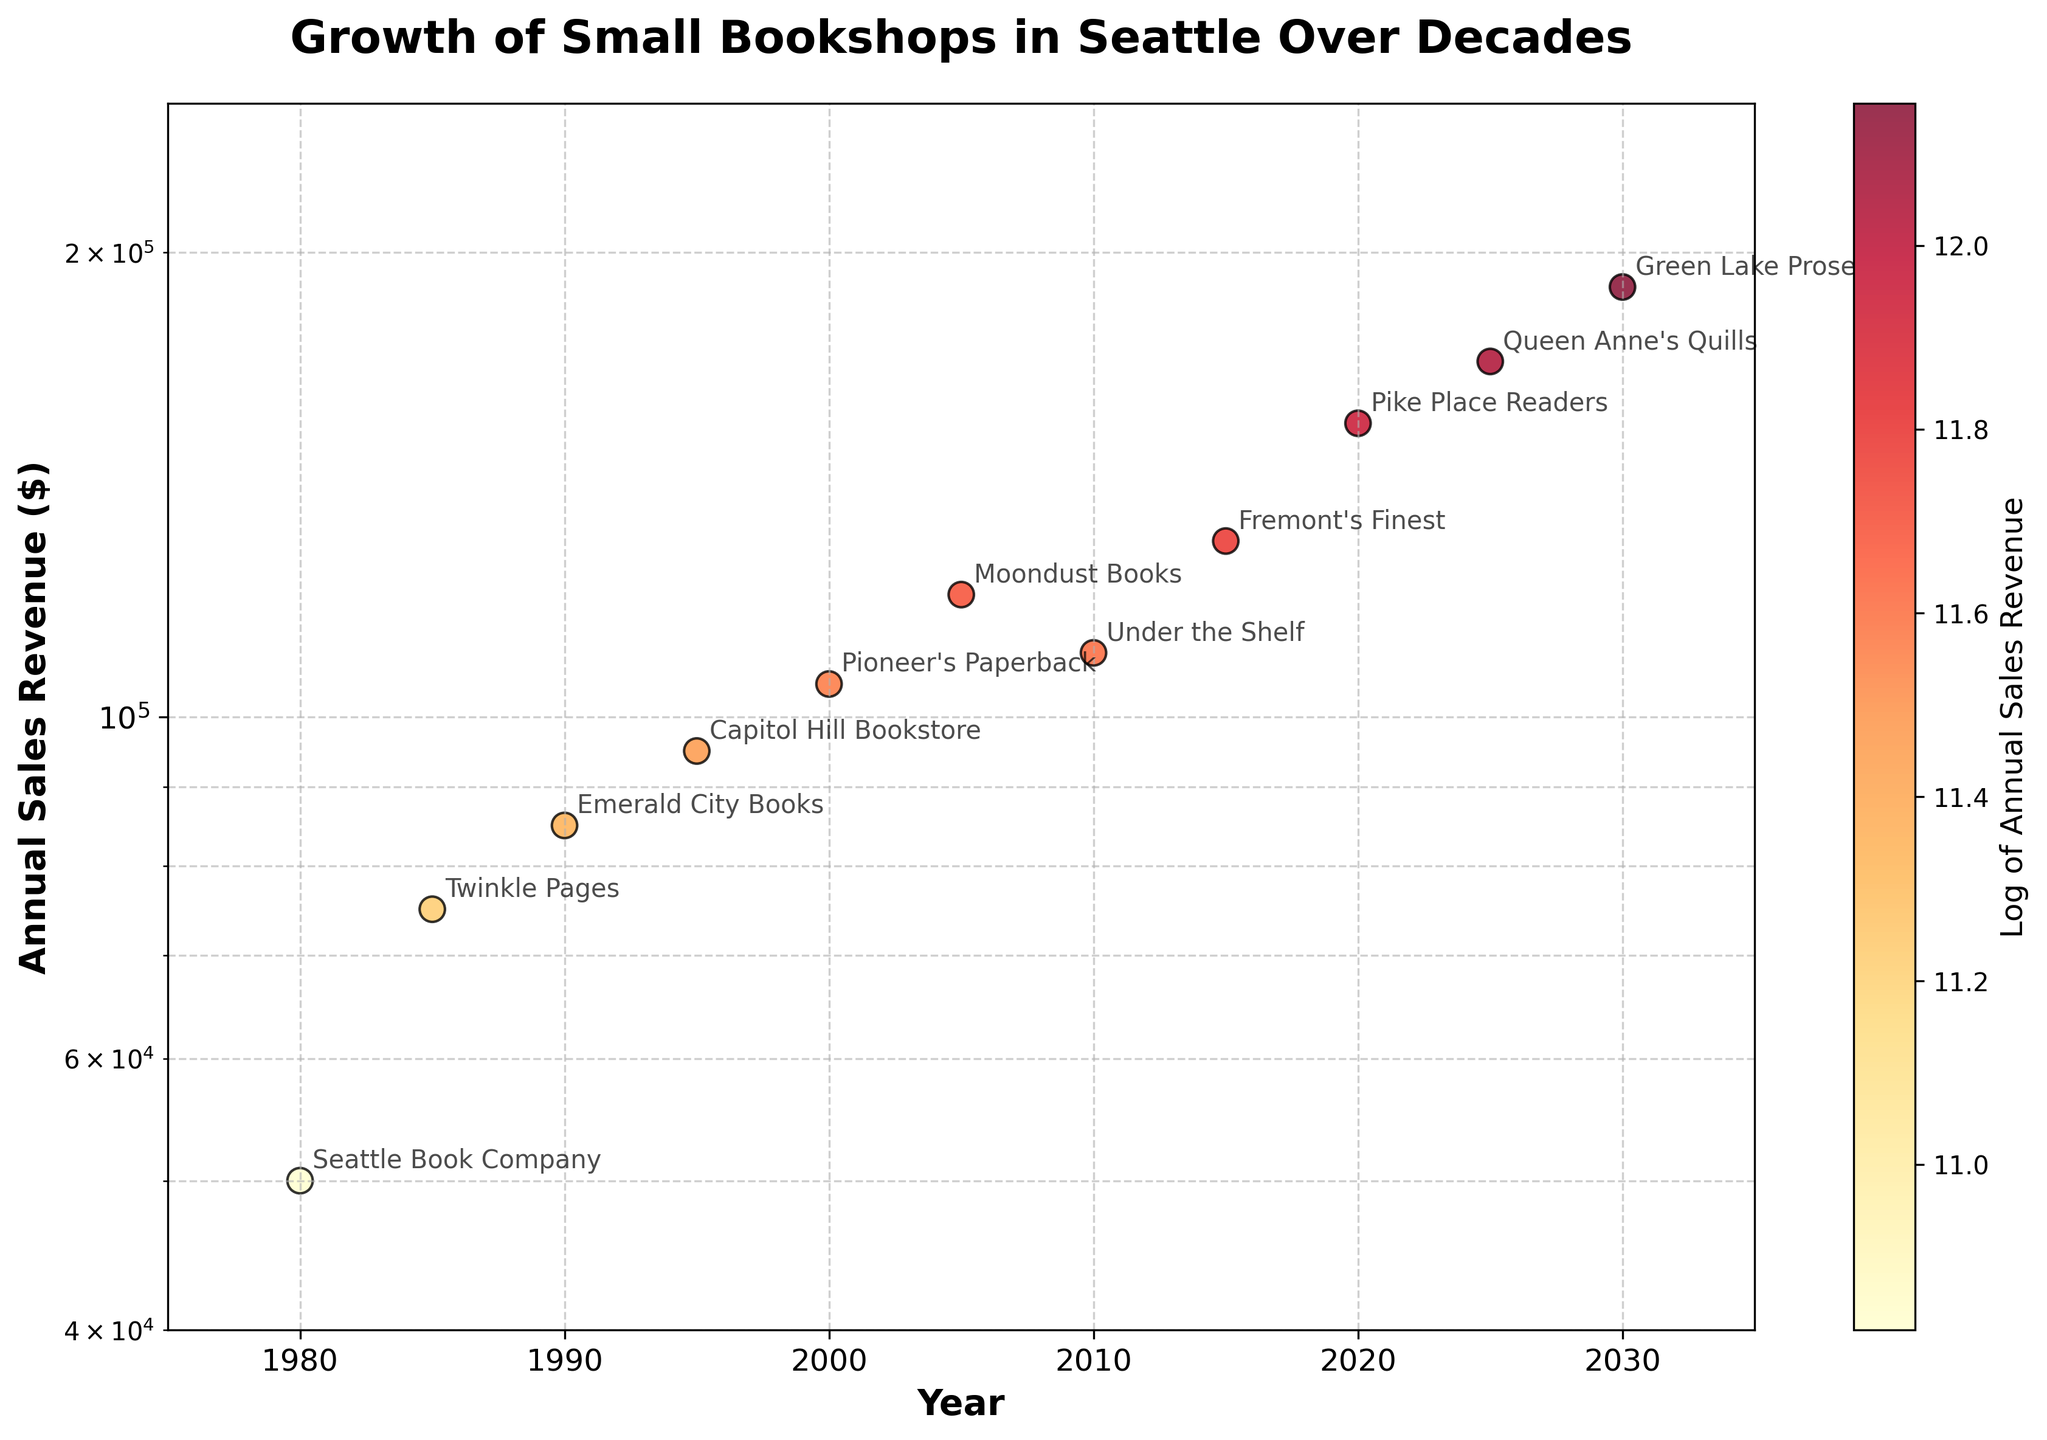What's the title of the scatter plot? The scatter plot has a single title located at the top center of the figure, and it reads "Growth of Small Bookshops in Seattle Over Decades".
Answer: Growth of Small Bookshops in Seattle Over Decades How many bookshops are represented in the scatter plot? Each data point represents a single bookshop, and by counting the points or the annotations, there are 11 bookshops shown in the plot.
Answer: 11 Which bookshop had the highest annual sales revenue in 2030? By examining the points in 2030 on the x-axis and their respective labels, we see that the highest annual sales revenue data point in 2030 is labeled "Green Lake Prose".
Answer: Green Lake Prose How does the annual sales revenue of Twinkle Pages in 1985 compare to Moondust Books in 2005? Twinkle Pages in 1985 has an annual revenue of 75,000, while Moondust Books in 2005 has 120,000. Comparing these values, Moondust Books had a higher annual sales revenue than Twinkle Pages.
Answer: Moondust Books had higher revenue What is the range of years displayed on the x-axis? The x-axis has values ranging from 1975 to 2035, as indicated by the axis limits in the plot.
Answer: 1975 to 2035 Have any bookshops shown a decline in annual sales revenue over the decades based on the visual trend? By following the trend lines formed by connecting the nearest points for each bookshop, it is evident that none of the bookshops display a declining trend in annual sales revenue over the decades.
Answer: None What is the color of the data points in the scatter plot, and what does it represent? The color of each data point ranges from yellow to red, representing the logarithm of the annual sales revenue, with darker colors indicating higher values.
Answer: Yellow to red, log of sales revenue Which bookshop had the lowest annual sales revenue, and in what year was this recorded? By identifying the lowest data point on the y-axis, we see that the "Seattle Book Company" in 1980 had the lowest annual sales revenue, which was 50,000.
Answer: Seattle Book Company, 1980 How does the annual sales revenue growth trend appear when considering the log scale? The log scale compresses larger values, making the increase in annual sales revenue appear less steep and more consistent over time instead of showing exponential growth.
Answer: Consistent growth What is the annotated log value of the highest annual sales revenue in the provided scatter plot? By checking the color bar and corresponding annotations, the highest log-scaled annual sales revenue value is around 12.06 for the "Green Lake Prose" in 2030 with a revenue of 190,000.
Answer: 12.06 